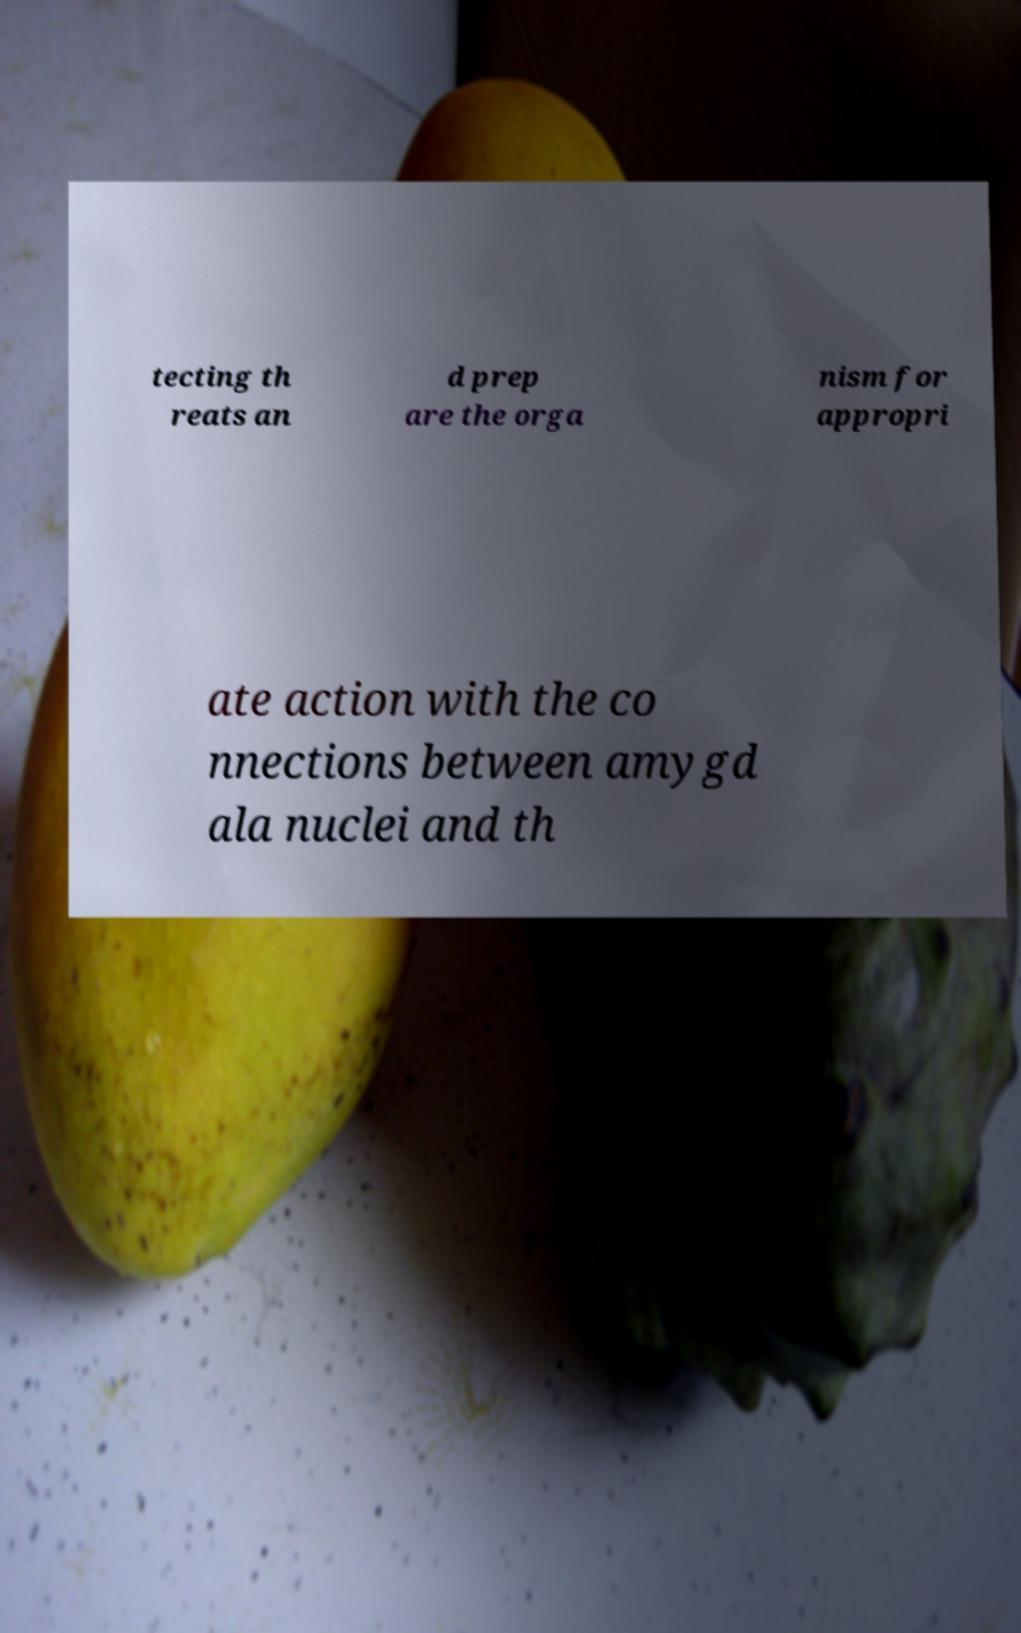Please identify and transcribe the text found in this image. tecting th reats an d prep are the orga nism for appropri ate action with the co nnections between amygd ala nuclei and th 